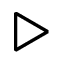<formula> <loc_0><loc_0><loc_500><loc_500>\triangleright</formula> 